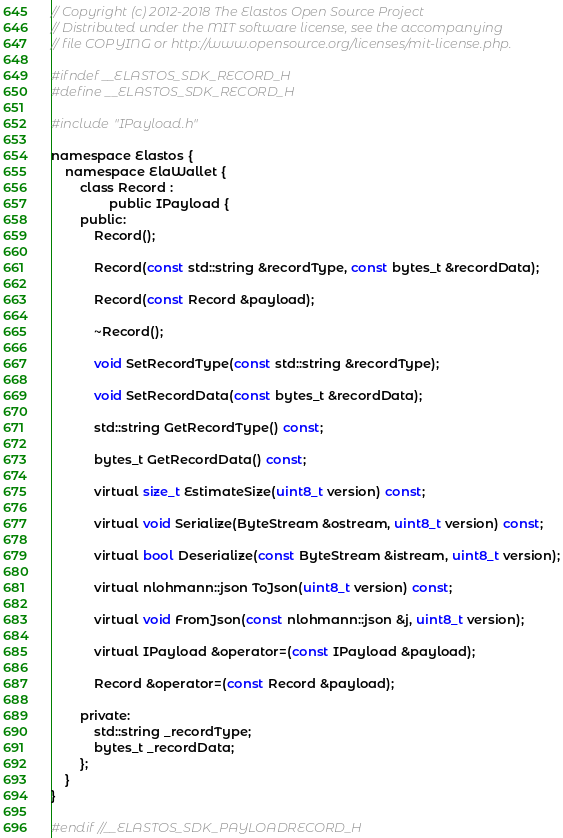Convert code to text. <code><loc_0><loc_0><loc_500><loc_500><_C_>// Copyright (c) 2012-2018 The Elastos Open Source Project
// Distributed under the MIT software license, see the accompanying
// file COPYING or http://www.opensource.org/licenses/mit-license.php.

#ifndef __ELASTOS_SDK_RECORD_H
#define __ELASTOS_SDK_RECORD_H

#include "IPayload.h"

namespace Elastos {
	namespace ElaWallet {
		class Record :
				public IPayload {
		public:
			Record();

			Record(const std::string &recordType, const bytes_t &recordData);

			Record(const Record &payload);

			~Record();

			void SetRecordType(const std::string &recordType);

			void SetRecordData(const bytes_t &recordData);

			std::string GetRecordType() const;

			bytes_t GetRecordData() const;

			virtual size_t EstimateSize(uint8_t version) const;

			virtual void Serialize(ByteStream &ostream, uint8_t version) const;

			virtual bool Deserialize(const ByteStream &istream, uint8_t version);

			virtual nlohmann::json ToJson(uint8_t version) const;

			virtual void FromJson(const nlohmann::json &j, uint8_t version);

			virtual IPayload &operator=(const IPayload &payload);

			Record &operator=(const Record &payload);

		private:
			std::string _recordType;
			bytes_t _recordData;
		};
	}
}

#endif //__ELASTOS_SDK_PAYLOADRECORD_H
</code> 